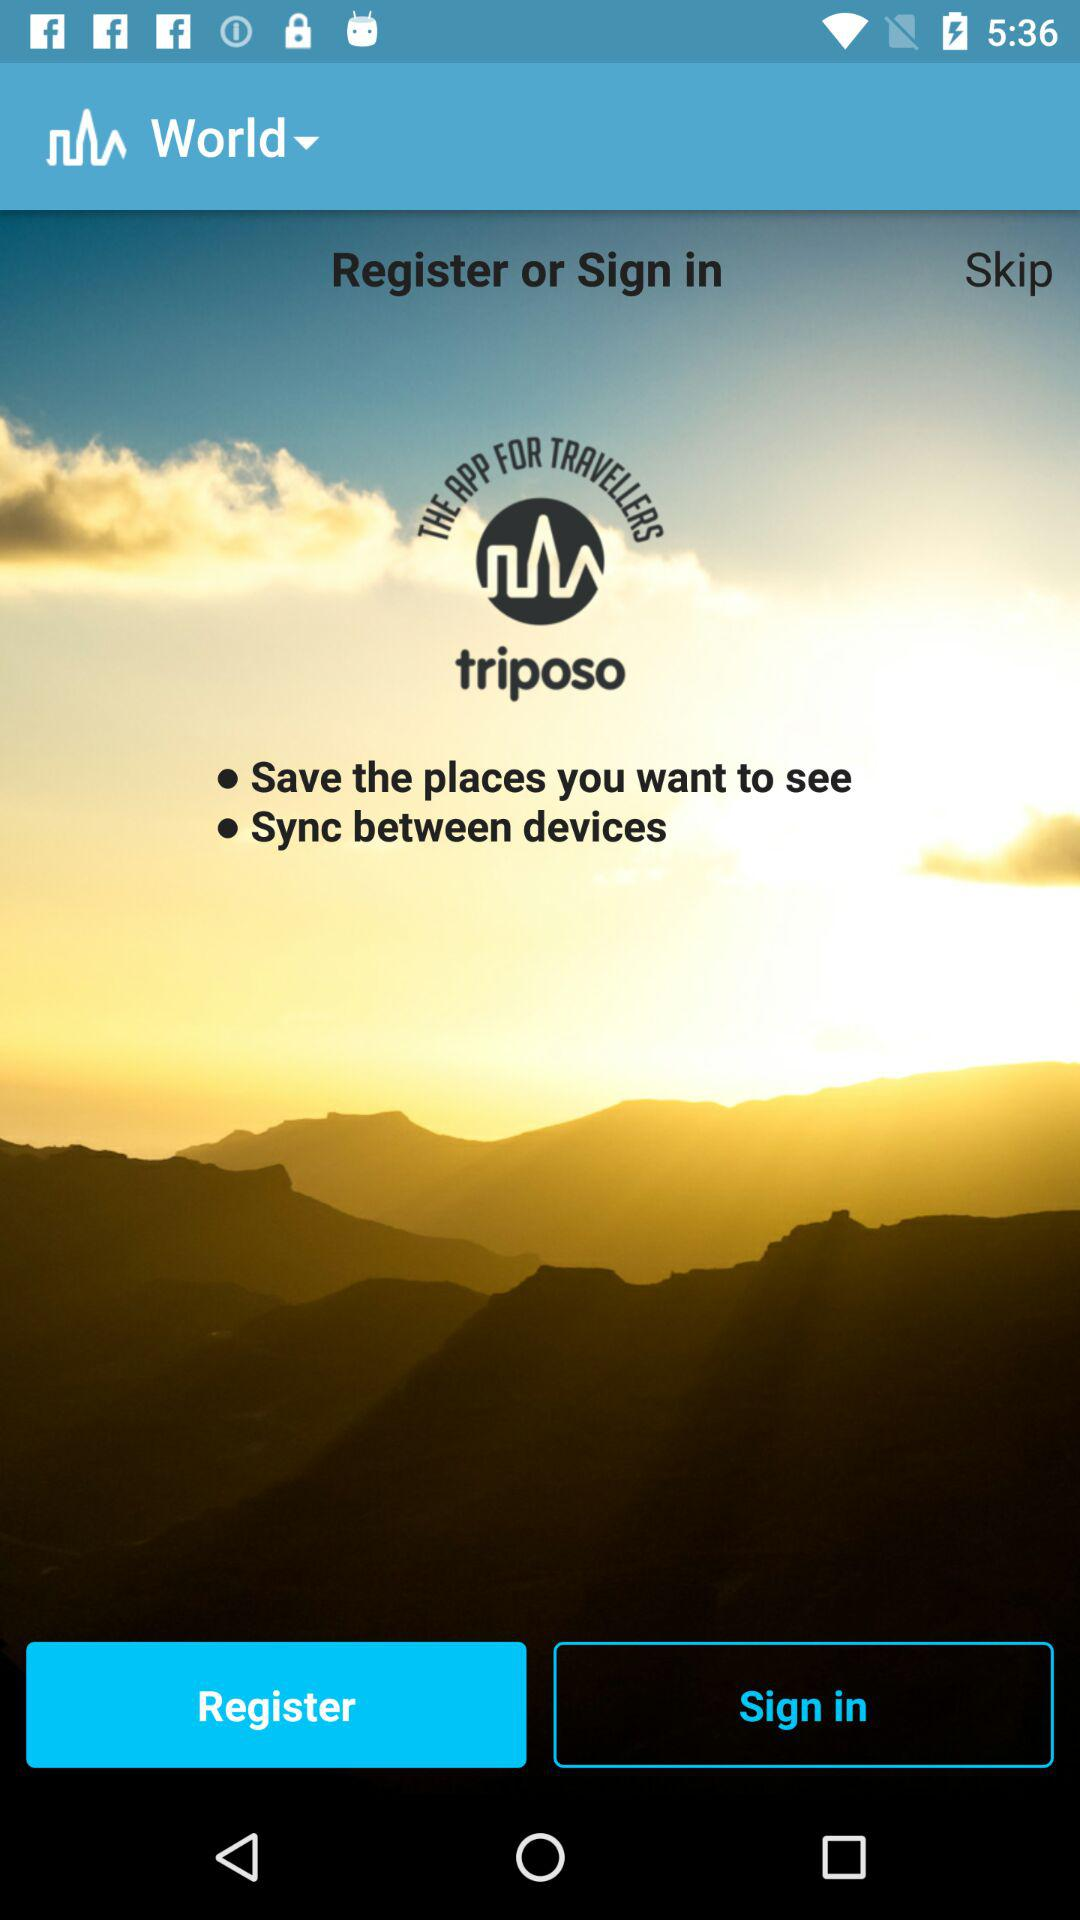What is the application name? The application name is "triposo". 